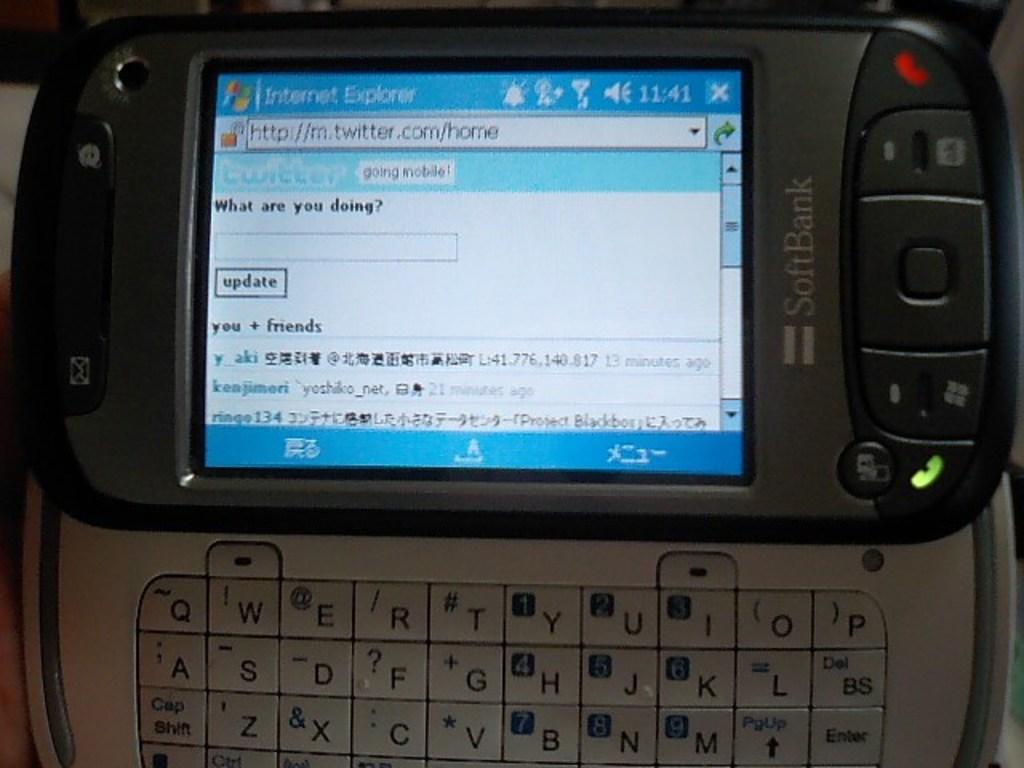The text is small, what is this device trying to tell me?
Offer a terse response. What are you doing?. What does the text say that was sent?
Provide a succinct answer. What are you doing?. 